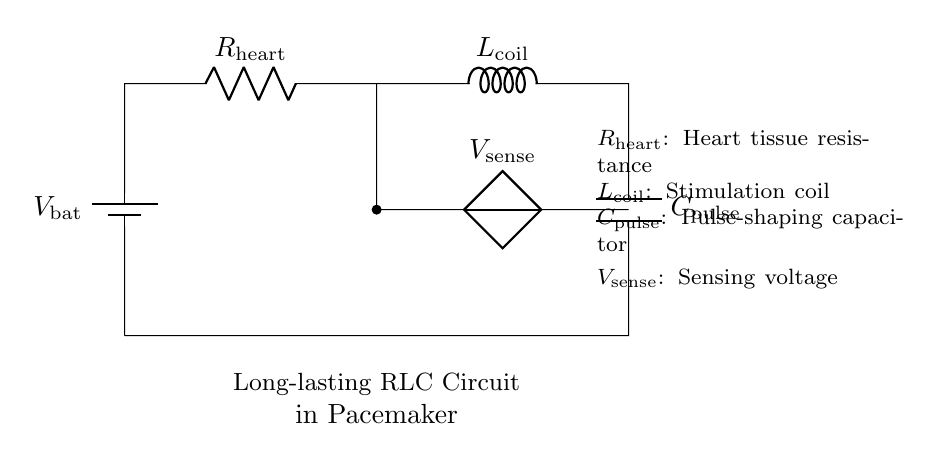What is the function of the battery in this circuit? The battery provides the voltage necessary for the circuit to operate. It supplies the electrical energy needed for the pacemaker to function, ensuring proper stimulation of the heart rhythms.
Answer: voltage What does the capacitor do in the RLC circuit? The capacitor shapes the pulses generated by the circuit, controlling the timing and duration of electrical impulses sent to the heart. Its role is essential for delivering precise signals to regulate heart rhythms.
Answer: pulse-shaping What type of circuit is represented here? This is an RLC circuit, which consists of a resistor, an inductor, and a capacitor working together to manage electrical signals effectively in the pacemaker.
Answer: RLC circuit What does the sensing voltage measure? The sensing voltage measures the electrical activity of the heart, allowing the pacemaker to monitor heart rhythms and respond appropriately to any irregularities.
Answer: electrical activity Why is an inductor used in this circuit? The inductor is used to store energy in the magnetic field and helps in smoothing or filtering the electrical signals produced by the circuit. This contributes to maintaining stable heart rhythms over time.
Answer: energy storage What components are included in this RLC circuit? The components include a battery, resistor, inductor (coil), and capacitor, each playing a distinct role in regulating the heart's electrical signals.
Answer: battery, resistor, inductor, capacitor 